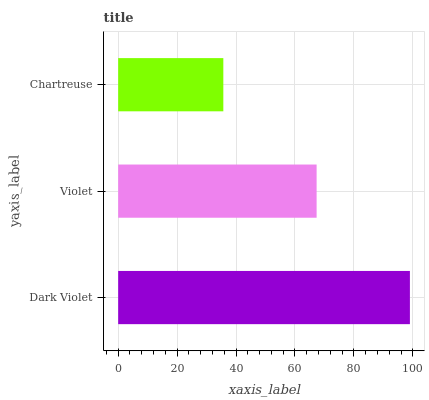Is Chartreuse the minimum?
Answer yes or no. Yes. Is Dark Violet the maximum?
Answer yes or no. Yes. Is Violet the minimum?
Answer yes or no. No. Is Violet the maximum?
Answer yes or no. No. Is Dark Violet greater than Violet?
Answer yes or no. Yes. Is Violet less than Dark Violet?
Answer yes or no. Yes. Is Violet greater than Dark Violet?
Answer yes or no. No. Is Dark Violet less than Violet?
Answer yes or no. No. Is Violet the high median?
Answer yes or no. Yes. Is Violet the low median?
Answer yes or no. Yes. Is Chartreuse the high median?
Answer yes or no. No. Is Dark Violet the low median?
Answer yes or no. No. 